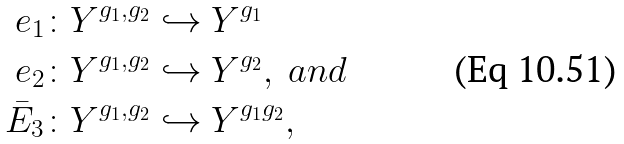Convert formula to latex. <formula><loc_0><loc_0><loc_500><loc_500>e _ { 1 } \colon & Y ^ { g _ { 1 } , g _ { 2 } } \hookrightarrow Y ^ { g _ { 1 } } \\ e _ { 2 } \colon & Y ^ { g _ { 1 } , g _ { 2 } } \hookrightarrow Y ^ { g _ { 2 } } , \ a n d \\ \bar { E } _ { 3 } \colon & Y ^ { g _ { 1 } , g _ { 2 } } \hookrightarrow Y ^ { g _ { 1 } g _ { 2 } } ,</formula> 